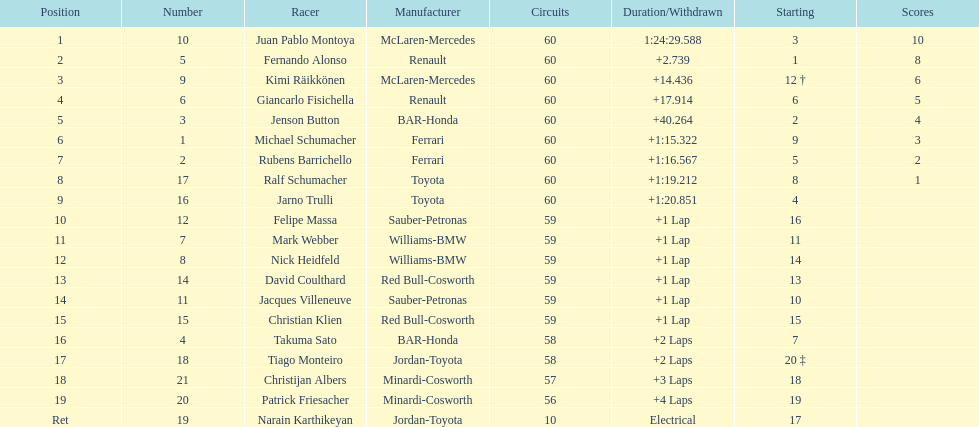How many drivers from germany? 3. 